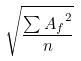Convert formula to latex. <formula><loc_0><loc_0><loc_500><loc_500>\sqrt { \frac { \sum { A _ { f } } ^ { 2 } } { n } }</formula> 